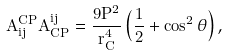<formula> <loc_0><loc_0><loc_500><loc_500>\hat { A } _ { i j } ^ { C P } \hat { A } ^ { i j } _ { C P } = \frac { 9 P ^ { 2 } } { r _ { C } ^ { 4 } } \left ( \frac { 1 } { 2 } + \cos ^ { 2 } \theta \right ) ,</formula> 